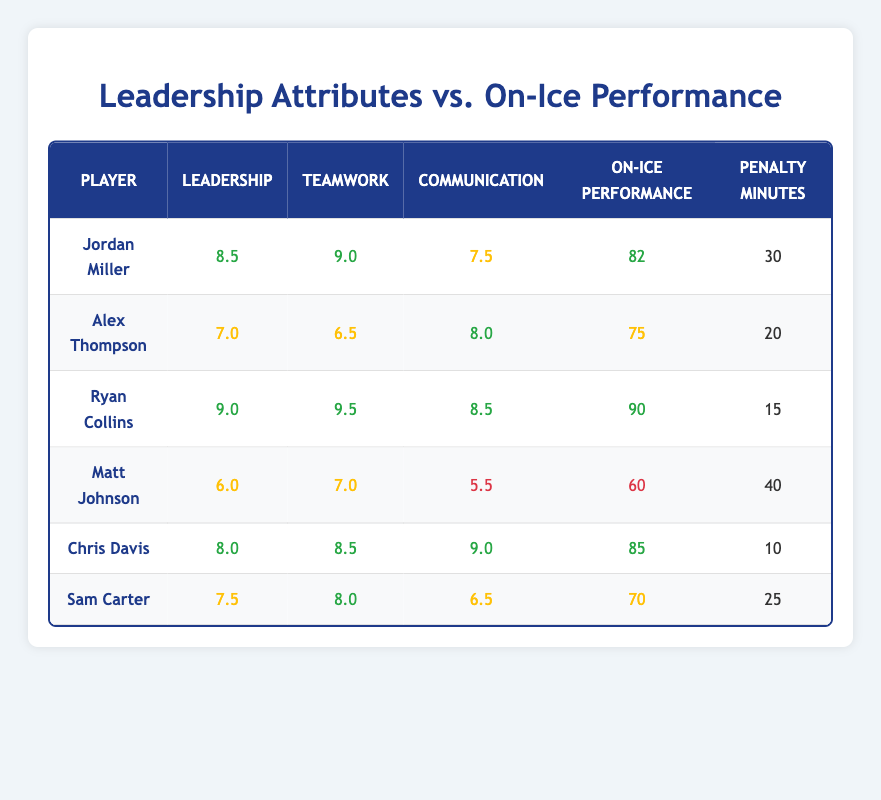What is the leadership score of Ryan Collins? Ryan Collins is listed in the table, and his leadership score is indicated directly in the relevant column.
Answer: 9.0 Which player has the highest on-ice performance score? By scanning through the on-ice performance scores listed for each player, Ryan Collins has the highest score of 90.
Answer: Ryan Collins What is the average penalty minutes for all players? We first add all the penalty minutes: 30 + 20 + 15 + 40 + 10 + 25 = 140. Then, we divide by the number of players (6), resulting in an average of 140/6 = 23.33.
Answer: 23.33 Does Jordan Miller have a lower teamwork score than Chris Davis? By comparing the teamwork scores listed for both players, Jordan Miller has a teamwork score of 9.0, while Chris Davis has 8.5, confirming that Miller has a higher score.
Answer: No Which player has the lowest leadership score, and what is that score? Looking through the leadership scores, Matt Johnson has the lowest score of 6.0.
Answer: Matt Johnson, 6.0 What is the total on-ice performance score for players with a leadership score greater than 7.5? We find the players with scores greater than 7.5: Jordan Miller (82), Ryan Collins (90), and Chris Davis (85). Summing these gives us 82 + 90 + 85 = 257.
Answer: 257 Is there a player with a penalty minute count of 15 or less? Scanning the penalty minutes column, we see that Ryan Collins has 15 penalty minutes, confirming there is one such player.
Answer: Yes What is the difference in communication scores between Ryan Collins and Matt Johnson? Ryan Collins has a communication score of 8.5, while Matt Johnson has 5.5. The difference is found by subtracting: 8.5 - 5.5 = 3.
Answer: 3 